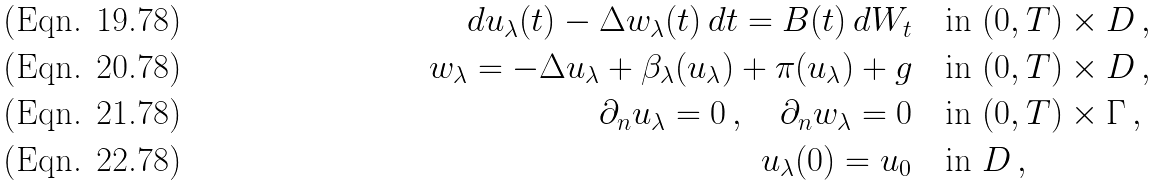Convert formula to latex. <formula><loc_0><loc_0><loc_500><loc_500>d u _ { \lambda } ( t ) - \Delta w _ { \lambda } ( t ) \, d t = B ( t ) \, d W _ { t } \quad & \text {in } ( 0 , T ) \times D \, , \\ w _ { \lambda } = - \Delta u _ { \lambda } + \beta _ { \lambda } ( u _ { \lambda } ) + \pi ( u _ { \lambda } ) + g \quad & \text {in } ( 0 , T ) \times D \, , \\ \partial _ { n } u _ { \lambda } = 0 \, , \quad \partial _ { n } w _ { \lambda } = 0 \quad & \text {in } ( 0 , T ) \times \Gamma \, , \\ u _ { \lambda } ( 0 ) = u _ { 0 } \quad & \text {in } D \, ,</formula> 